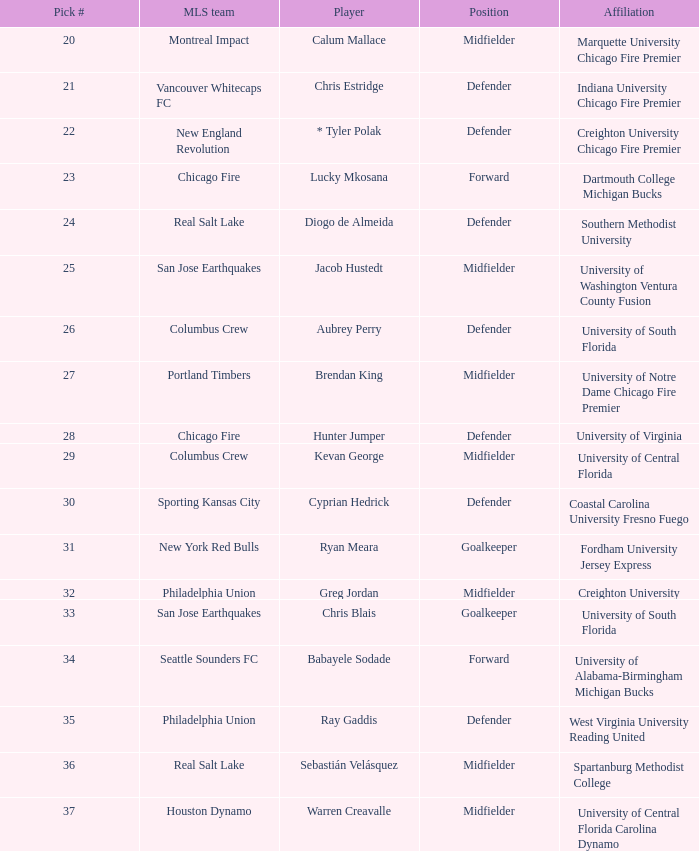Who was pick number 34? Babayele Sodade. 